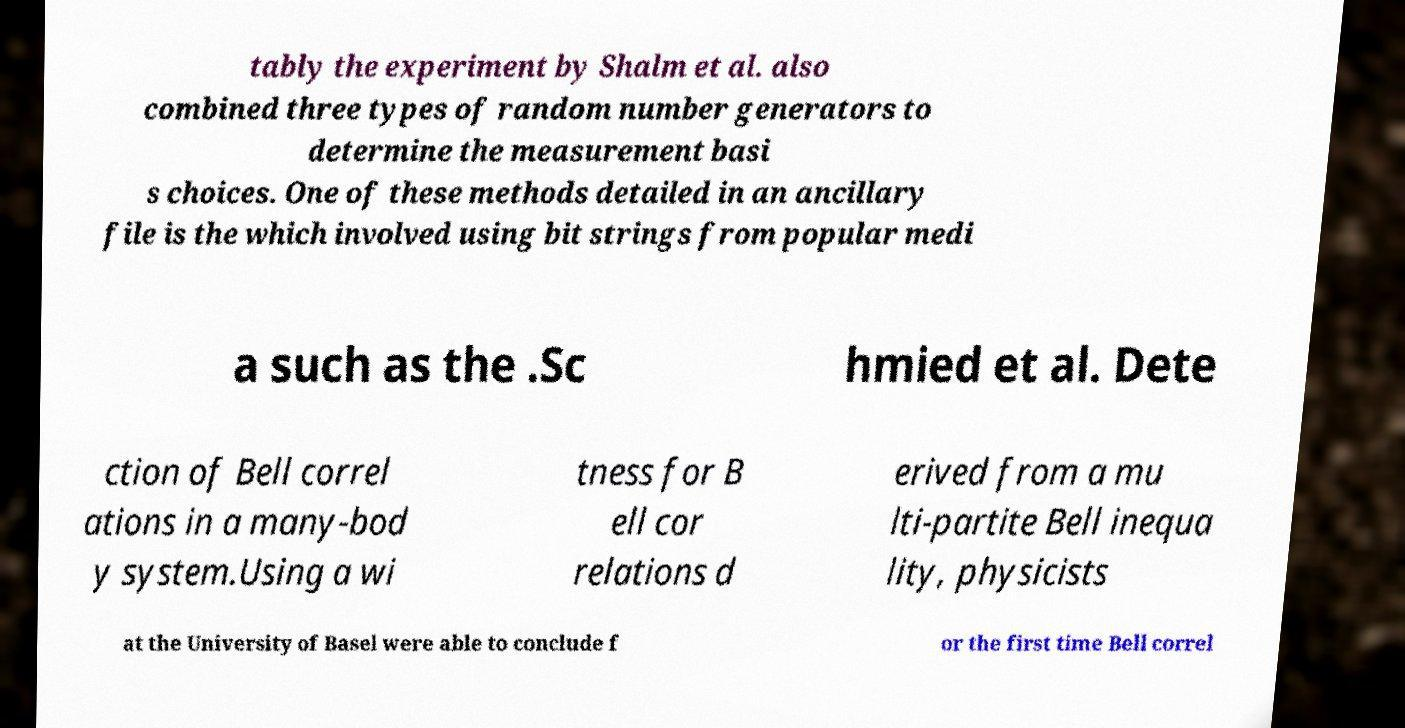Could you extract and type out the text from this image? tably the experiment by Shalm et al. also combined three types of random number generators to determine the measurement basi s choices. One of these methods detailed in an ancillary file is the which involved using bit strings from popular medi a such as the .Sc hmied et al. Dete ction of Bell correl ations in a many-bod y system.Using a wi tness for B ell cor relations d erived from a mu lti-partite Bell inequa lity, physicists at the University of Basel were able to conclude f or the first time Bell correl 